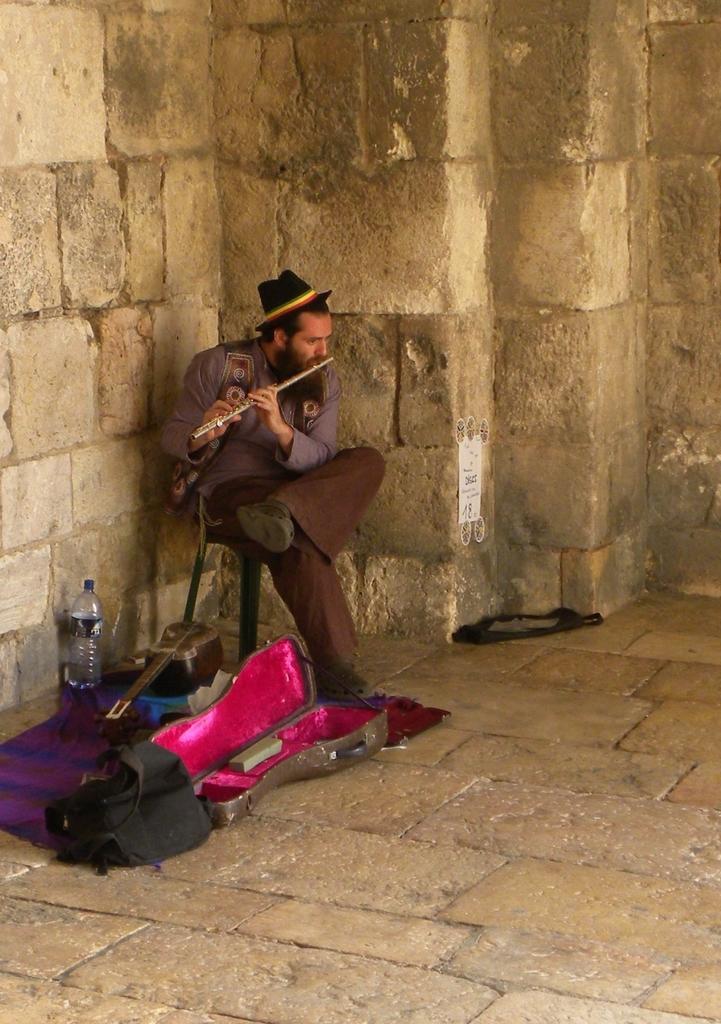In one or two sentences, can you explain what this image depicts? there is a person sitting on the chair and playing flute,on the floor there is musical instrument cloth and a bottle. 